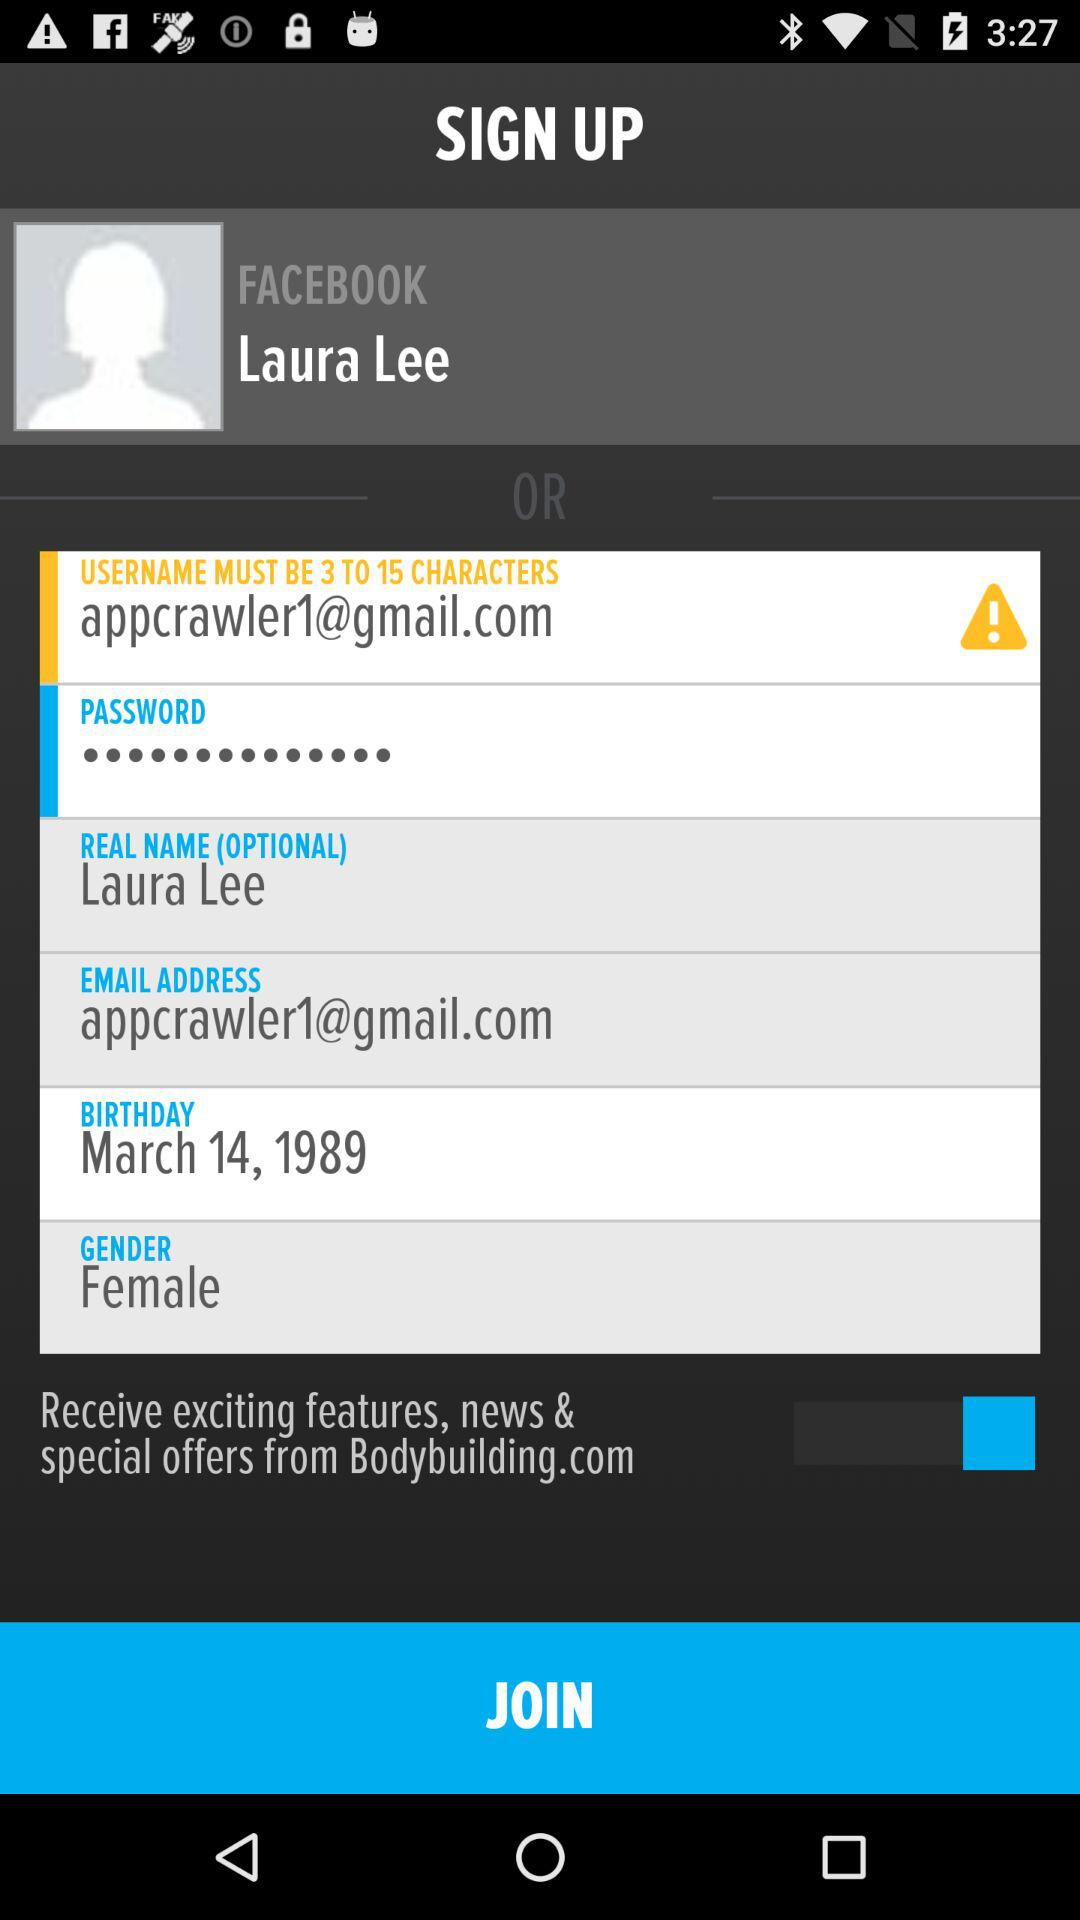What is the user name? The user name is Laura Lee. 